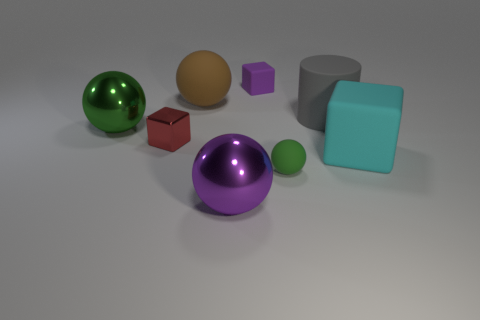Subtract all large brown balls. How many balls are left? 3 Subtract all blue spheres. Subtract all gray blocks. How many spheres are left? 4 Add 1 tiny blue metal objects. How many objects exist? 9 Subtract all cylinders. How many objects are left? 7 Add 4 green metallic objects. How many green metallic objects are left? 5 Add 4 big cyan matte things. How many big cyan matte things exist? 5 Subtract 0 cyan spheres. How many objects are left? 8 Subtract all large brown balls. Subtract all small metallic blocks. How many objects are left? 6 